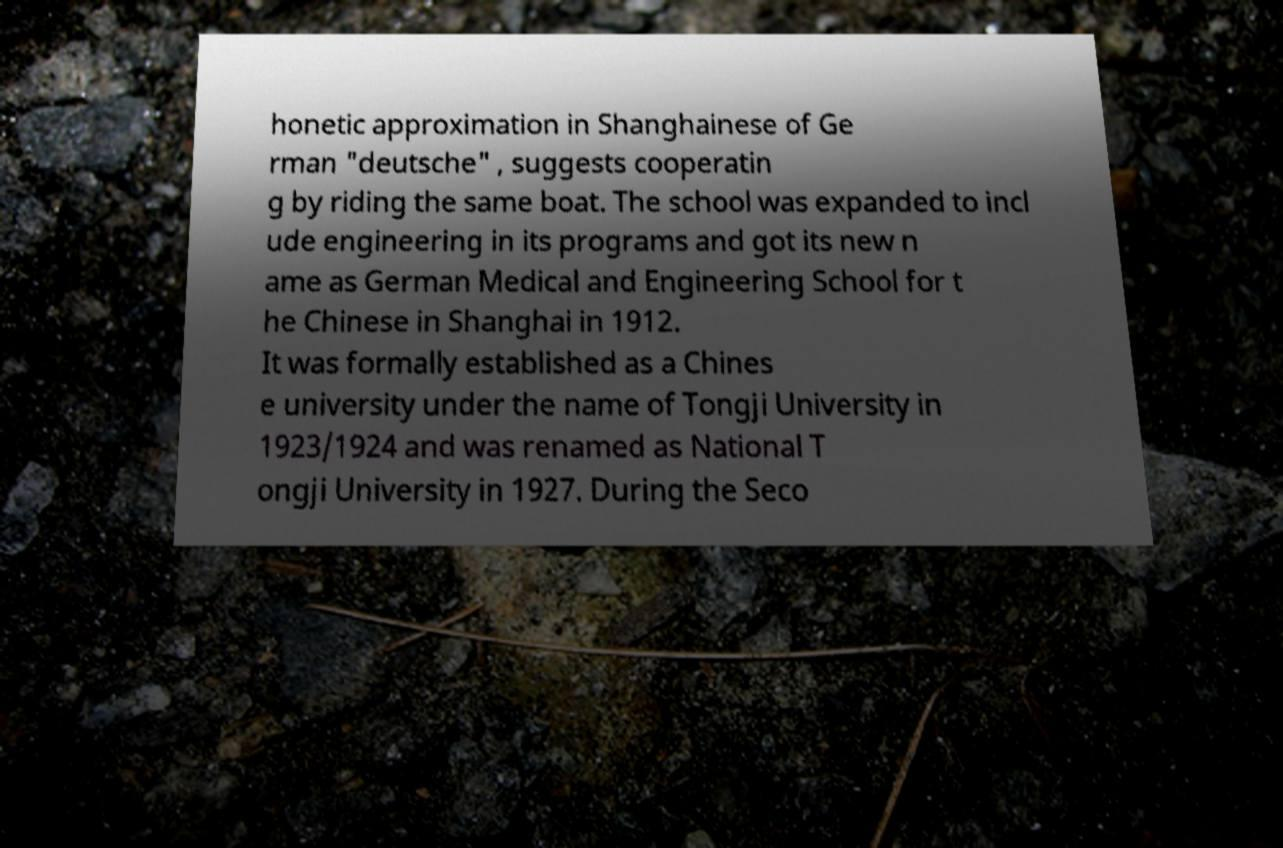Can you accurately transcribe the text from the provided image for me? honetic approximation in Shanghainese of Ge rman "deutsche" , suggests cooperatin g by riding the same boat. The school was expanded to incl ude engineering in its programs and got its new n ame as German Medical and Engineering School for t he Chinese in Shanghai in 1912. It was formally established as a Chines e university under the name of Tongji University in 1923/1924 and was renamed as National T ongji University in 1927. During the Seco 